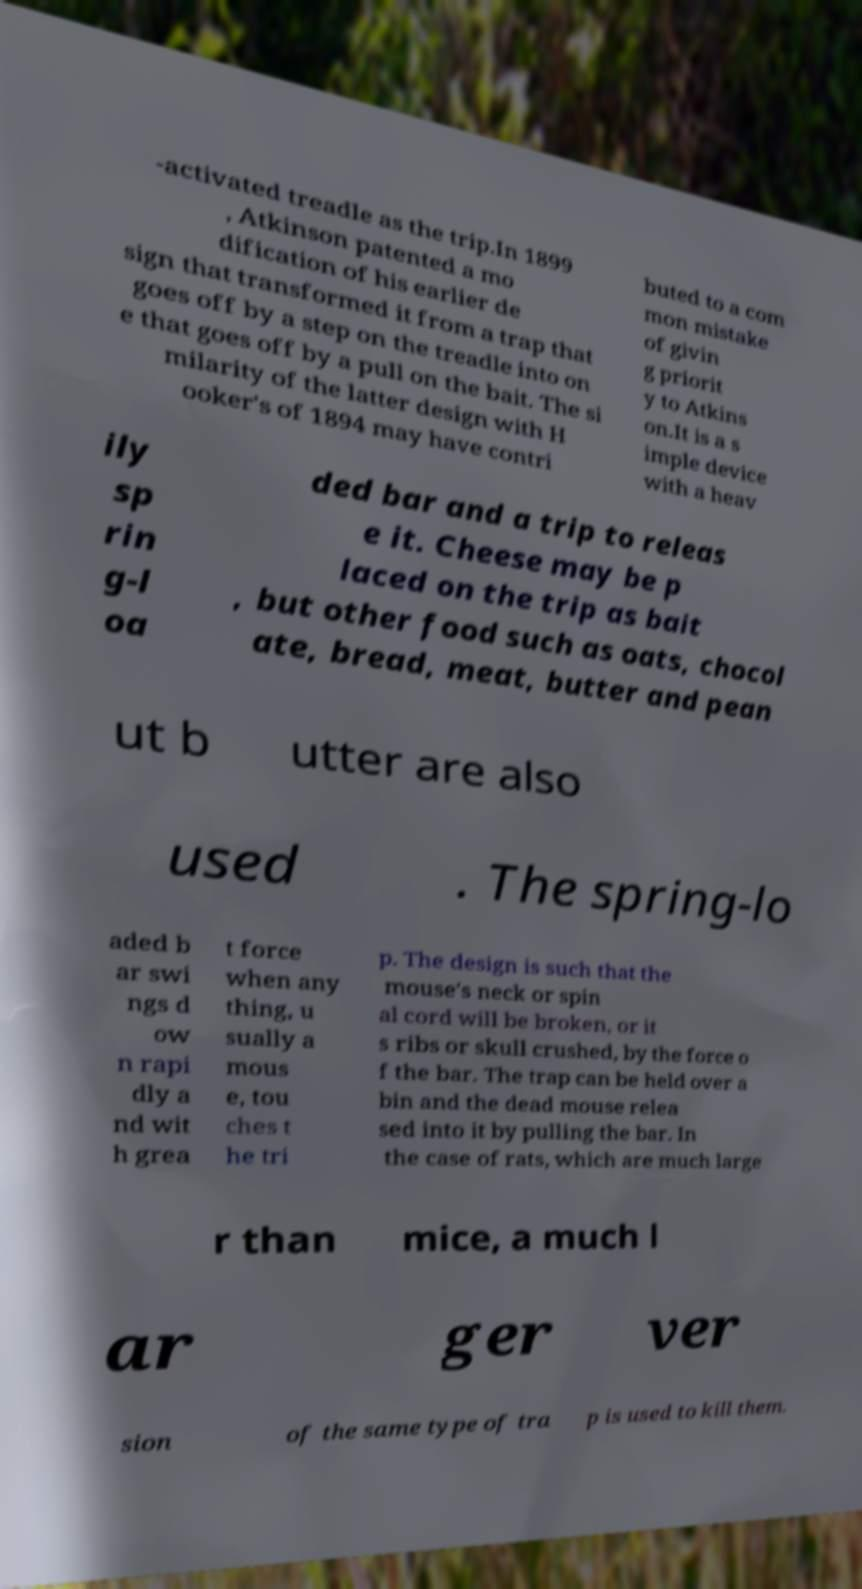Could you extract and type out the text from this image? -activated treadle as the trip.In 1899 , Atkinson patented a mo dification of his earlier de sign that transformed it from a trap that goes off by a step on the treadle into on e that goes off by a pull on the bait. The si milarity of the latter design with H ooker's of 1894 may have contri buted to a com mon mistake of givin g priorit y to Atkins on.It is a s imple device with a heav ily sp rin g-l oa ded bar and a trip to releas e it. Cheese may be p laced on the trip as bait , but other food such as oats, chocol ate, bread, meat, butter and pean ut b utter are also used . The spring-lo aded b ar swi ngs d ow n rapi dly a nd wit h grea t force when any thing, u sually a mous e, tou ches t he tri p. The design is such that the mouse's neck or spin al cord will be broken, or it s ribs or skull crushed, by the force o f the bar. The trap can be held over a bin and the dead mouse relea sed into it by pulling the bar. In the case of rats, which are much large r than mice, a much l ar ger ver sion of the same type of tra p is used to kill them. 